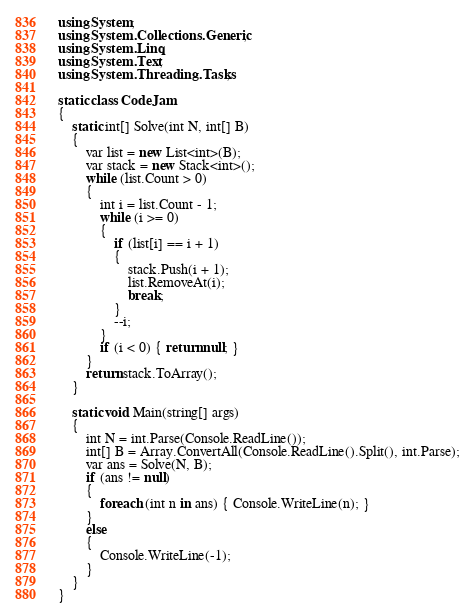Convert code to text. <code><loc_0><loc_0><loc_500><loc_500><_C#_>using System;
using System.Collections.Generic;
using System.Linq;
using System.Text;
using System.Threading.Tasks;

static class CodeJam
{
    static int[] Solve(int N, int[] B)
    {
        var list = new List<int>(B);
        var stack = new Stack<int>();
        while (list.Count > 0)
        {
            int i = list.Count - 1;
            while (i >= 0)
            {
                if (list[i] == i + 1)
                {
                    stack.Push(i + 1);
                    list.RemoveAt(i);
                    break;
                }
                --i;
            }
            if (i < 0) { return null; }
        }
        return stack.ToArray();
    }

    static void Main(string[] args)
    {
        int N = int.Parse(Console.ReadLine());
        int[] B = Array.ConvertAll(Console.ReadLine().Split(), int.Parse);
        var ans = Solve(N, B);
        if (ans != null)
        {
            foreach (int n in ans) { Console.WriteLine(n); }
        }
        else
        {
            Console.WriteLine(-1);
        }
    }
}
</code> 